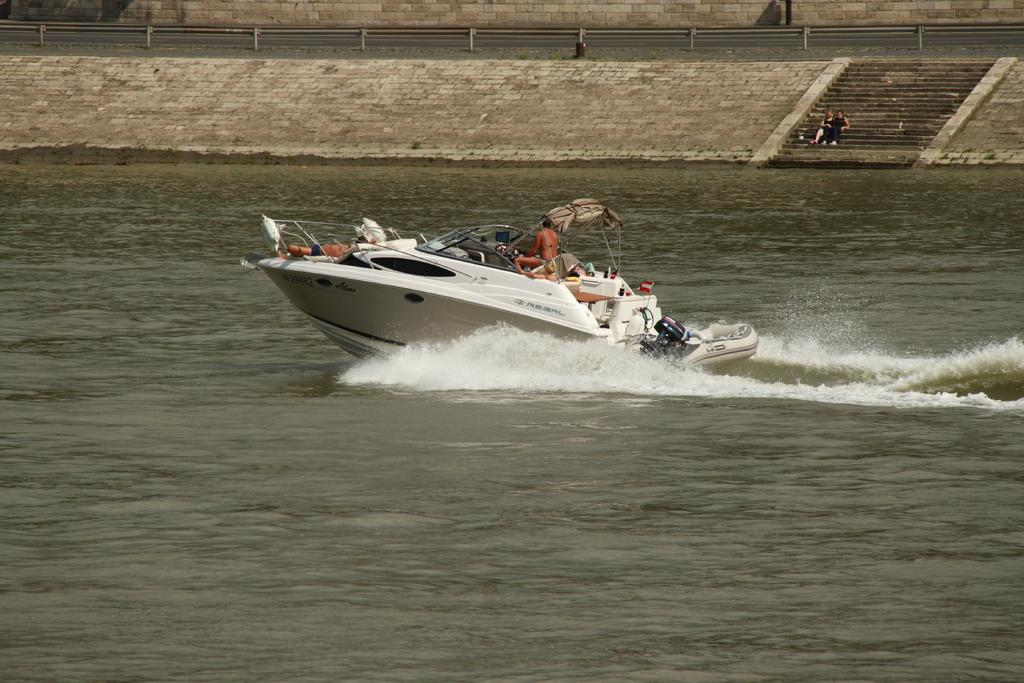What activity are the people in the image engaged in? The people in the image are sailing a boat. Where is the boat located? The boat is on the water. Can you describe the people sitting on the stairs? There are two people sitting on stairs in the image. What objects can be seen in the image that are used for fishing or similar activities? There are rods visible in the image. What type of structure is present in the image? There is a wall in the image. What type of insect is crawling on the wall in the image? There is no insect visible on the wall in the image. What invention is being used by the people sailing the boat? The image does not provide enough information to determine which specific invention is being used by the people sailing the boat. 